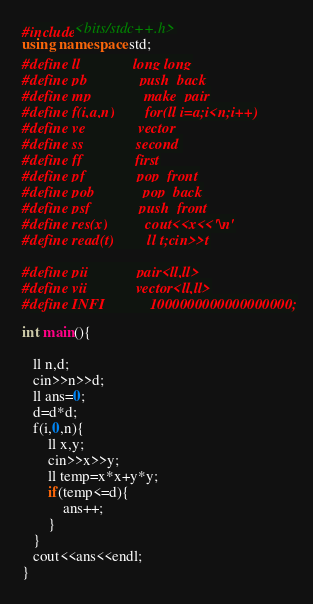Convert code to text. <code><loc_0><loc_0><loc_500><loc_500><_C++_>#include<bits/stdc++.h>
using namespace std;
#define ll              long long
#define pb              push_back
#define mp              make_pair
#define f(i,a,n)        for(ll i=a;i<n;i++)
#define ve              vector
#define ss              second 
#define ff              first
#define pf              pop_front
#define pob             pop_back
#define psf             push_front
#define res(x)          cout<<x<<'\n'
#define read(t)         ll t;cin>>t

#define pii             pair<ll,ll>
#define vii             vector<ll,ll>
#define INFI            1000000000000000000;

int main(){
   
   ll n,d;
   cin>>n>>d;
   ll ans=0;
   d=d*d;
   f(i,0,n){
       ll x,y;
       cin>>x>>y;
       ll temp=x*x+y*y;
       if(temp<=d){
           ans++;
       }
   }
   cout<<ans<<endl;
}</code> 